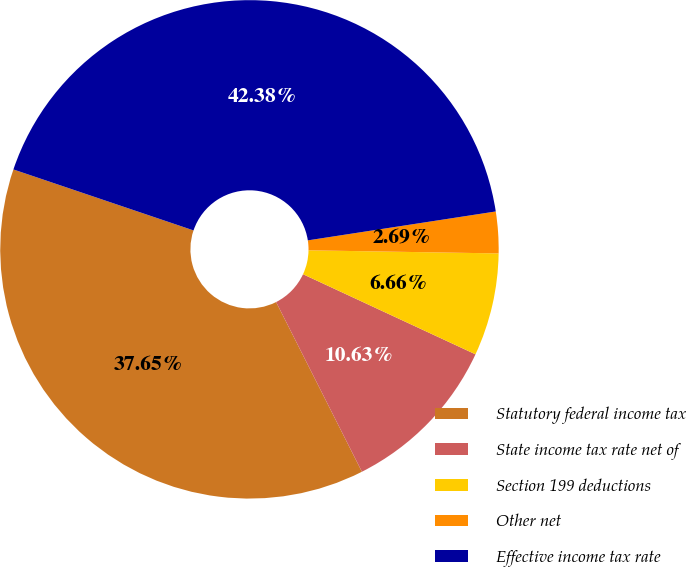Convert chart to OTSL. <chart><loc_0><loc_0><loc_500><loc_500><pie_chart><fcel>Statutory federal income tax<fcel>State income tax rate net of<fcel>Section 199 deductions<fcel>Other net<fcel>Effective income tax rate<nl><fcel>37.65%<fcel>10.63%<fcel>6.66%<fcel>2.69%<fcel>42.38%<nl></chart> 